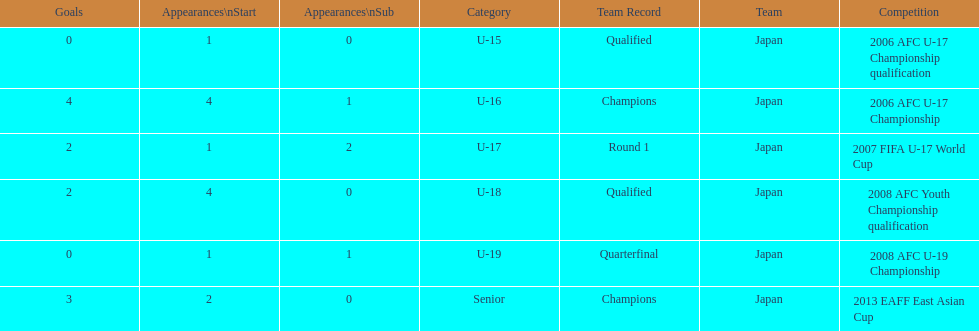How many goals were scored in total? 11. 